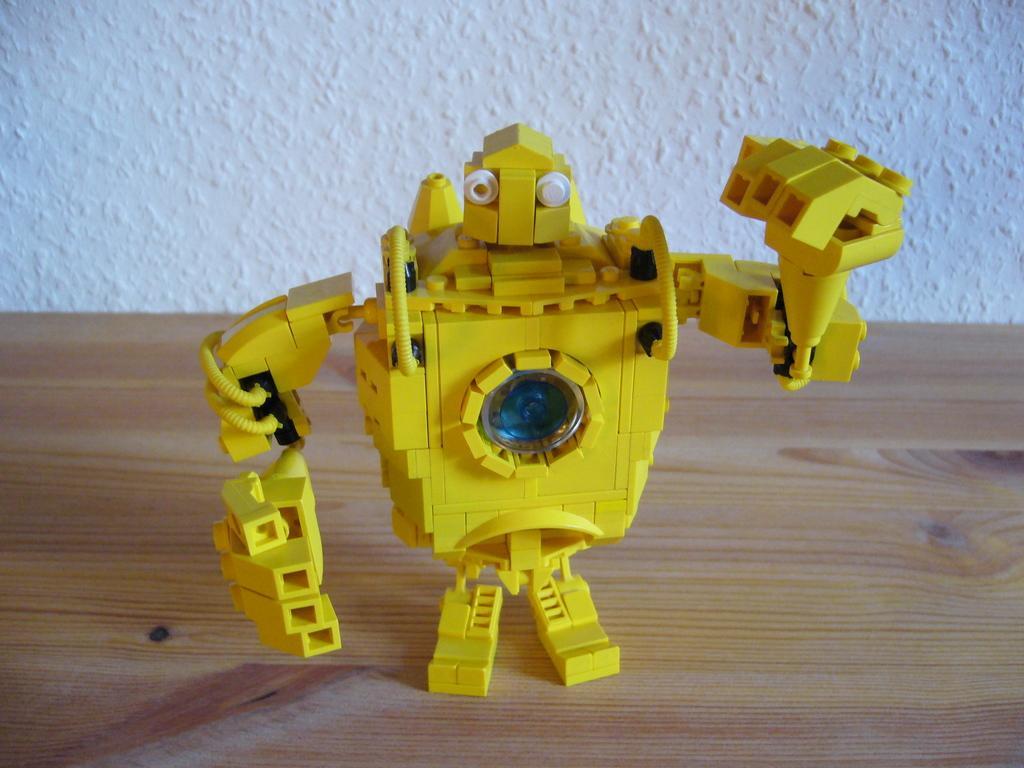Could you give a brief overview of what you see in this image? This image is taken indoors. In the background there is a wall. At the bottom of the image there is a table. In the middle of the image there is a toy robot on the table. 